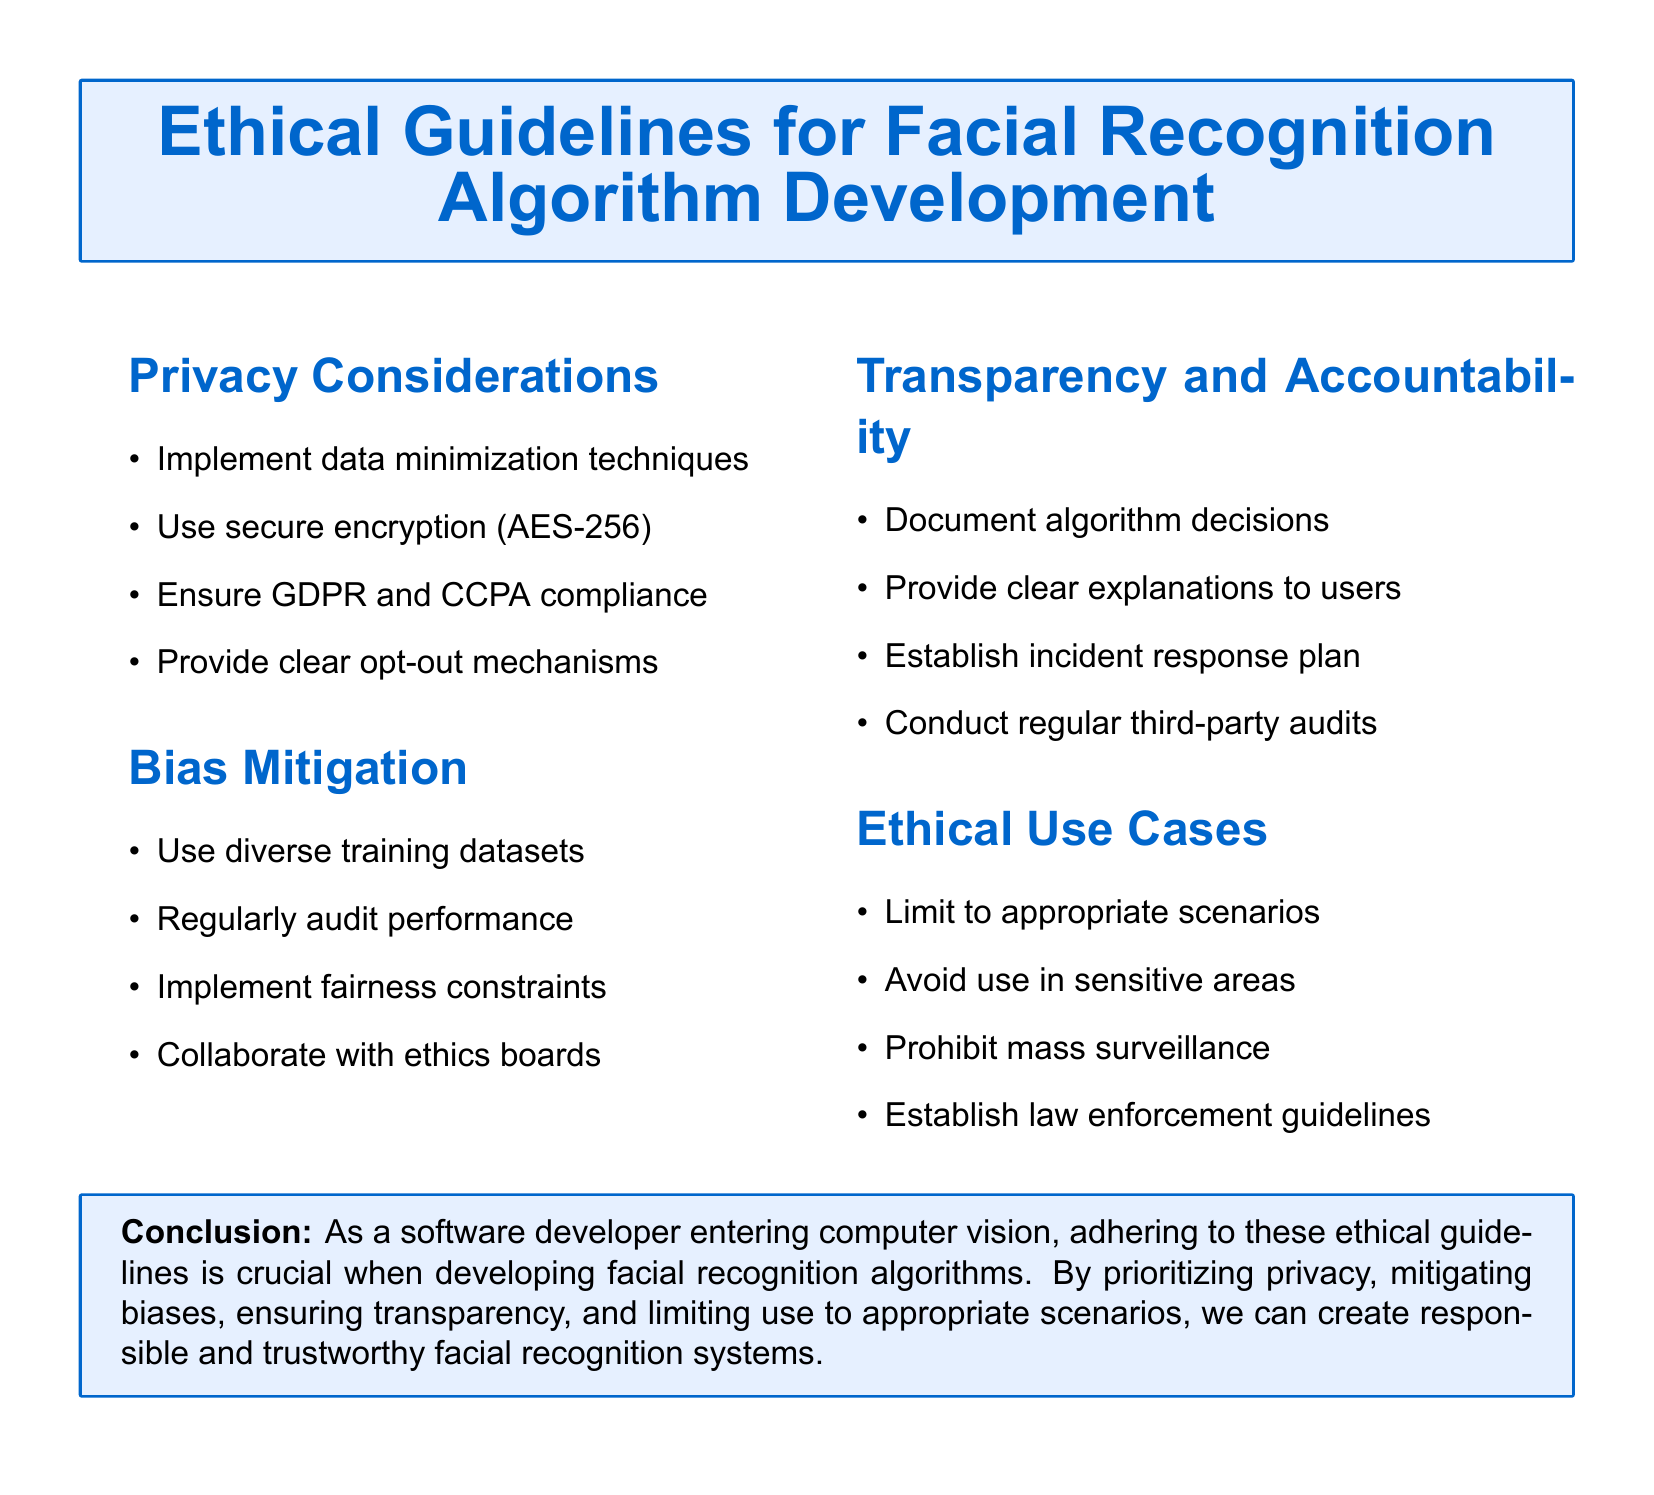What is the encryption standard recommended? The encryption standard recommended in the document for secure data is AES-256.
Answer: AES-256 What does GDPR stand for in the context of privacy considerations? GDPR refers to the General Data Protection Regulation, which is a compliance framework mentioned in the privacy considerations section.
Answer: General Data Protection Regulation Which section discusses the use of diverse training datasets? The use of diverse training datasets is discussed in the Bias Mitigation section of the document.
Answer: Bias Mitigation What should be documented according to the Transparency and Accountability section? The Transparency and Accountability section states that algorithm decisions should be documented.
Answer: Algorithm decisions What is one of the ethical use cases highlighted in the document? One of the ethical use cases highlighted is to limit the use of facial recognition algorithms to appropriate scenarios.
Answer: Appropriate scenarios What is a recommended action to mitigate bias during development? A recommended action to mitigate bias is to regularly audit performance of the algorithms.
Answer: Regularly audit performance What type of guidelines does the document prohibit in relation to ethical use cases? The document prohibits guidelines for mass surveillance in ethical use cases.
Answer: Mass surveillance 